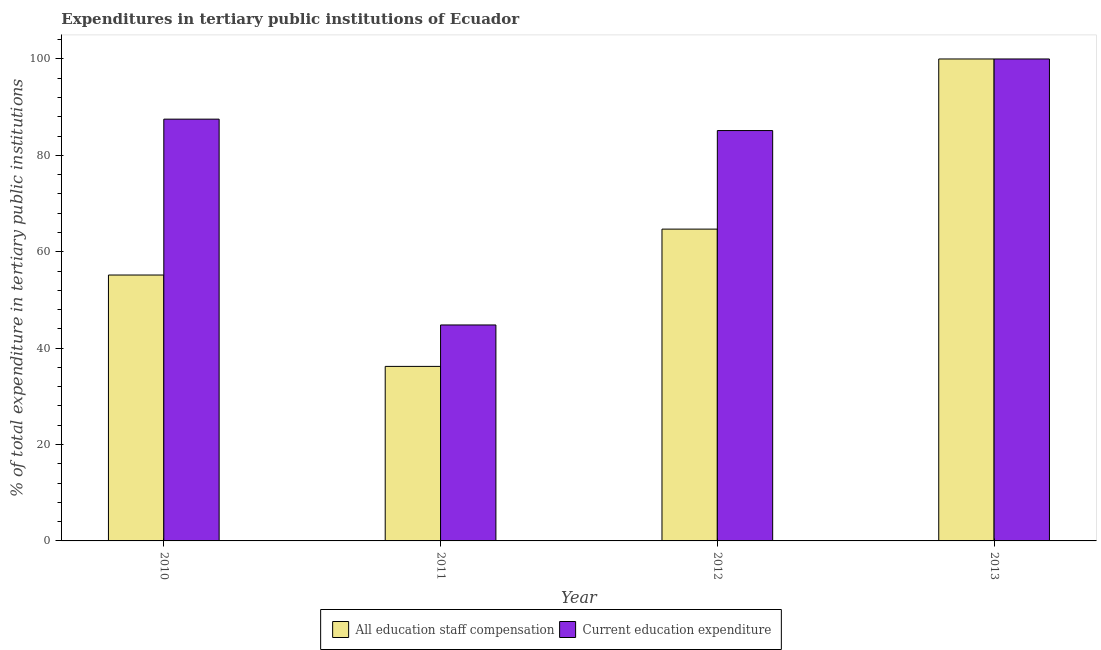How many different coloured bars are there?
Offer a very short reply. 2. How many groups of bars are there?
Make the answer very short. 4. Are the number of bars per tick equal to the number of legend labels?
Your response must be concise. Yes. Are the number of bars on each tick of the X-axis equal?
Offer a very short reply. Yes. How many bars are there on the 2nd tick from the left?
Keep it short and to the point. 2. How many bars are there on the 3rd tick from the right?
Offer a terse response. 2. What is the label of the 1st group of bars from the left?
Offer a very short reply. 2010. What is the expenditure in education in 2011?
Your answer should be very brief. 44.81. Across all years, what is the minimum expenditure in education?
Provide a succinct answer. 44.81. What is the total expenditure in staff compensation in the graph?
Provide a succinct answer. 256.08. What is the difference between the expenditure in staff compensation in 2011 and that in 2013?
Give a very brief answer. -63.79. What is the difference between the expenditure in education in 2012 and the expenditure in staff compensation in 2011?
Your response must be concise. 40.34. What is the average expenditure in staff compensation per year?
Provide a short and direct response. 64.02. In the year 2010, what is the difference between the expenditure in education and expenditure in staff compensation?
Your answer should be compact. 0. What is the ratio of the expenditure in education in 2010 to that in 2013?
Make the answer very short. 0.88. Is the difference between the expenditure in education in 2011 and 2012 greater than the difference between the expenditure in staff compensation in 2011 and 2012?
Ensure brevity in your answer.  No. What is the difference between the highest and the second highest expenditure in staff compensation?
Your answer should be very brief. 35.3. What is the difference between the highest and the lowest expenditure in staff compensation?
Give a very brief answer. 63.79. In how many years, is the expenditure in staff compensation greater than the average expenditure in staff compensation taken over all years?
Make the answer very short. 2. Is the sum of the expenditure in education in 2011 and 2012 greater than the maximum expenditure in staff compensation across all years?
Give a very brief answer. Yes. What does the 1st bar from the left in 2011 represents?
Your answer should be compact. All education staff compensation. What does the 2nd bar from the right in 2013 represents?
Your answer should be very brief. All education staff compensation. How many bars are there?
Provide a succinct answer. 8. What is the difference between two consecutive major ticks on the Y-axis?
Make the answer very short. 20. Does the graph contain any zero values?
Make the answer very short. No. Does the graph contain grids?
Make the answer very short. No. How are the legend labels stacked?
Provide a short and direct response. Horizontal. What is the title of the graph?
Make the answer very short. Expenditures in tertiary public institutions of Ecuador. Does "Mineral" appear as one of the legend labels in the graph?
Provide a succinct answer. No. What is the label or title of the X-axis?
Your answer should be compact. Year. What is the label or title of the Y-axis?
Provide a short and direct response. % of total expenditure in tertiary public institutions. What is the % of total expenditure in tertiary public institutions of All education staff compensation in 2010?
Keep it short and to the point. 55.17. What is the % of total expenditure in tertiary public institutions of Current education expenditure in 2010?
Provide a short and direct response. 87.52. What is the % of total expenditure in tertiary public institutions in All education staff compensation in 2011?
Your response must be concise. 36.21. What is the % of total expenditure in tertiary public institutions in Current education expenditure in 2011?
Your response must be concise. 44.81. What is the % of total expenditure in tertiary public institutions in All education staff compensation in 2012?
Provide a succinct answer. 64.7. What is the % of total expenditure in tertiary public institutions in Current education expenditure in 2012?
Ensure brevity in your answer.  85.15. Across all years, what is the maximum % of total expenditure in tertiary public institutions of Current education expenditure?
Provide a succinct answer. 100. Across all years, what is the minimum % of total expenditure in tertiary public institutions of All education staff compensation?
Offer a terse response. 36.21. Across all years, what is the minimum % of total expenditure in tertiary public institutions of Current education expenditure?
Provide a succinct answer. 44.81. What is the total % of total expenditure in tertiary public institutions in All education staff compensation in the graph?
Give a very brief answer. 256.08. What is the total % of total expenditure in tertiary public institutions in Current education expenditure in the graph?
Give a very brief answer. 317.47. What is the difference between the % of total expenditure in tertiary public institutions of All education staff compensation in 2010 and that in 2011?
Your answer should be very brief. 18.96. What is the difference between the % of total expenditure in tertiary public institutions in Current education expenditure in 2010 and that in 2011?
Offer a very short reply. 42.71. What is the difference between the % of total expenditure in tertiary public institutions of All education staff compensation in 2010 and that in 2012?
Make the answer very short. -9.52. What is the difference between the % of total expenditure in tertiary public institutions of Current education expenditure in 2010 and that in 2012?
Your answer should be compact. 2.37. What is the difference between the % of total expenditure in tertiary public institutions of All education staff compensation in 2010 and that in 2013?
Offer a terse response. -44.83. What is the difference between the % of total expenditure in tertiary public institutions of Current education expenditure in 2010 and that in 2013?
Your answer should be very brief. -12.48. What is the difference between the % of total expenditure in tertiary public institutions in All education staff compensation in 2011 and that in 2012?
Make the answer very short. -28.48. What is the difference between the % of total expenditure in tertiary public institutions of Current education expenditure in 2011 and that in 2012?
Your answer should be compact. -40.34. What is the difference between the % of total expenditure in tertiary public institutions of All education staff compensation in 2011 and that in 2013?
Ensure brevity in your answer.  -63.79. What is the difference between the % of total expenditure in tertiary public institutions of Current education expenditure in 2011 and that in 2013?
Your answer should be very brief. -55.19. What is the difference between the % of total expenditure in tertiary public institutions of All education staff compensation in 2012 and that in 2013?
Your answer should be compact. -35.3. What is the difference between the % of total expenditure in tertiary public institutions of Current education expenditure in 2012 and that in 2013?
Make the answer very short. -14.85. What is the difference between the % of total expenditure in tertiary public institutions of All education staff compensation in 2010 and the % of total expenditure in tertiary public institutions of Current education expenditure in 2011?
Offer a terse response. 10.36. What is the difference between the % of total expenditure in tertiary public institutions in All education staff compensation in 2010 and the % of total expenditure in tertiary public institutions in Current education expenditure in 2012?
Your answer should be very brief. -29.97. What is the difference between the % of total expenditure in tertiary public institutions in All education staff compensation in 2010 and the % of total expenditure in tertiary public institutions in Current education expenditure in 2013?
Provide a succinct answer. -44.83. What is the difference between the % of total expenditure in tertiary public institutions in All education staff compensation in 2011 and the % of total expenditure in tertiary public institutions in Current education expenditure in 2012?
Ensure brevity in your answer.  -48.93. What is the difference between the % of total expenditure in tertiary public institutions of All education staff compensation in 2011 and the % of total expenditure in tertiary public institutions of Current education expenditure in 2013?
Your answer should be very brief. -63.79. What is the difference between the % of total expenditure in tertiary public institutions in All education staff compensation in 2012 and the % of total expenditure in tertiary public institutions in Current education expenditure in 2013?
Provide a short and direct response. -35.3. What is the average % of total expenditure in tertiary public institutions in All education staff compensation per year?
Your answer should be compact. 64.02. What is the average % of total expenditure in tertiary public institutions in Current education expenditure per year?
Provide a short and direct response. 79.37. In the year 2010, what is the difference between the % of total expenditure in tertiary public institutions of All education staff compensation and % of total expenditure in tertiary public institutions of Current education expenditure?
Your response must be concise. -32.34. In the year 2011, what is the difference between the % of total expenditure in tertiary public institutions in All education staff compensation and % of total expenditure in tertiary public institutions in Current education expenditure?
Your response must be concise. -8.6. In the year 2012, what is the difference between the % of total expenditure in tertiary public institutions of All education staff compensation and % of total expenditure in tertiary public institutions of Current education expenditure?
Keep it short and to the point. -20.45. In the year 2013, what is the difference between the % of total expenditure in tertiary public institutions of All education staff compensation and % of total expenditure in tertiary public institutions of Current education expenditure?
Provide a short and direct response. 0. What is the ratio of the % of total expenditure in tertiary public institutions in All education staff compensation in 2010 to that in 2011?
Your response must be concise. 1.52. What is the ratio of the % of total expenditure in tertiary public institutions in Current education expenditure in 2010 to that in 2011?
Provide a succinct answer. 1.95. What is the ratio of the % of total expenditure in tertiary public institutions of All education staff compensation in 2010 to that in 2012?
Keep it short and to the point. 0.85. What is the ratio of the % of total expenditure in tertiary public institutions of Current education expenditure in 2010 to that in 2012?
Provide a succinct answer. 1.03. What is the ratio of the % of total expenditure in tertiary public institutions of All education staff compensation in 2010 to that in 2013?
Your answer should be very brief. 0.55. What is the ratio of the % of total expenditure in tertiary public institutions of Current education expenditure in 2010 to that in 2013?
Keep it short and to the point. 0.88. What is the ratio of the % of total expenditure in tertiary public institutions of All education staff compensation in 2011 to that in 2012?
Your answer should be compact. 0.56. What is the ratio of the % of total expenditure in tertiary public institutions in Current education expenditure in 2011 to that in 2012?
Provide a succinct answer. 0.53. What is the ratio of the % of total expenditure in tertiary public institutions of All education staff compensation in 2011 to that in 2013?
Provide a succinct answer. 0.36. What is the ratio of the % of total expenditure in tertiary public institutions of Current education expenditure in 2011 to that in 2013?
Give a very brief answer. 0.45. What is the ratio of the % of total expenditure in tertiary public institutions of All education staff compensation in 2012 to that in 2013?
Ensure brevity in your answer.  0.65. What is the ratio of the % of total expenditure in tertiary public institutions in Current education expenditure in 2012 to that in 2013?
Your response must be concise. 0.85. What is the difference between the highest and the second highest % of total expenditure in tertiary public institutions in All education staff compensation?
Your response must be concise. 35.3. What is the difference between the highest and the second highest % of total expenditure in tertiary public institutions in Current education expenditure?
Make the answer very short. 12.48. What is the difference between the highest and the lowest % of total expenditure in tertiary public institutions of All education staff compensation?
Offer a terse response. 63.79. What is the difference between the highest and the lowest % of total expenditure in tertiary public institutions of Current education expenditure?
Your answer should be very brief. 55.19. 